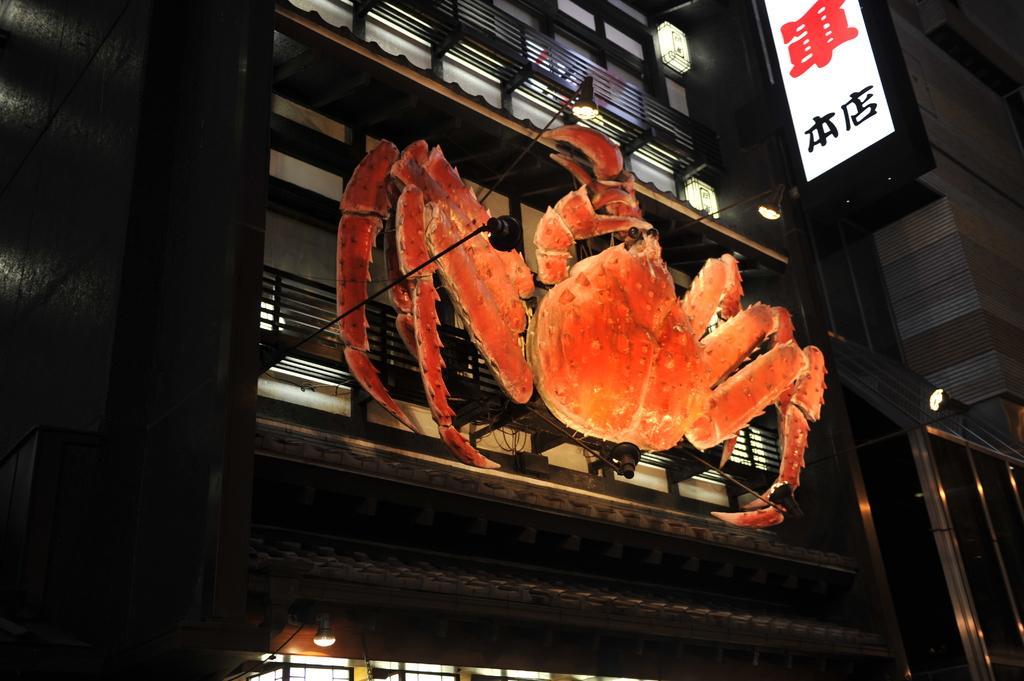Can you describe this image briefly? In this image I can see an orange color object in the shape of crab. To the right I can see the board and lights. I can also see the railing. 